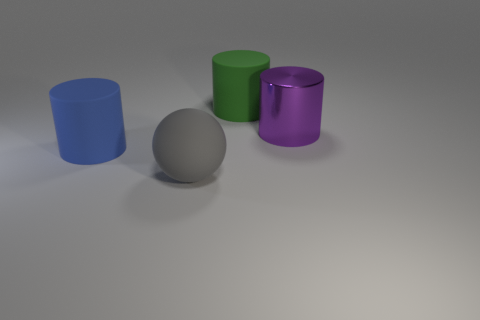There is a rubber cylinder on the right side of the gray matte thing; is its size the same as the large purple metallic thing?
Give a very brief answer. Yes. How many things are either big things to the left of the purple cylinder or purple shiny cylinders behind the big gray thing?
Provide a succinct answer. 4. Do the large matte sphere and the big metallic object have the same color?
Make the answer very short. No. Is the number of big green rubber things that are on the right side of the big purple cylinder less than the number of big green things to the left of the big blue cylinder?
Offer a terse response. No. Is the green cylinder made of the same material as the large sphere?
Make the answer very short. Yes. What size is the object that is both right of the blue rubber cylinder and to the left of the large green object?
Offer a very short reply. Large. What is the shape of the blue thing that is the same size as the gray matte thing?
Provide a short and direct response. Cylinder. What material is the cylinder that is left of the matte cylinder behind the big thing that is on the right side of the green matte thing?
Offer a very short reply. Rubber. There is a large matte thing that is behind the large purple object; is its shape the same as the big blue matte thing in front of the big purple thing?
Offer a very short reply. Yes. How many other things are made of the same material as the large gray ball?
Your response must be concise. 2. 